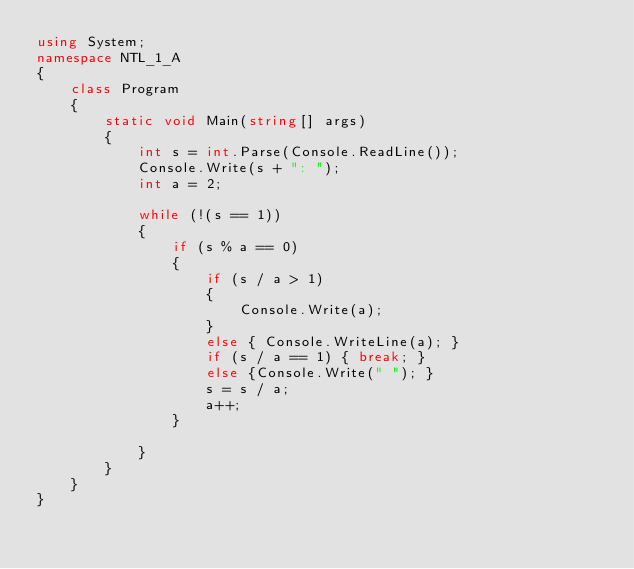<code> <loc_0><loc_0><loc_500><loc_500><_C#_>using System;
namespace NTL_1_A
{
    class Program
    {
        static void Main(string[] args)
        {
            int s = int.Parse(Console.ReadLine());
            Console.Write(s + ": ");
            int a = 2;

            while (!(s == 1))
            {
                if (s % a == 0)
                {
                    if (s / a > 1)
                    {
                        Console.Write(a);
                    }
                    else { Console.WriteLine(a); }
                    if (s / a == 1) { break; }
                    else {Console.Write(" "); }
                    s = s / a;
                    a++;
                }

            }
        }
    }
}</code> 